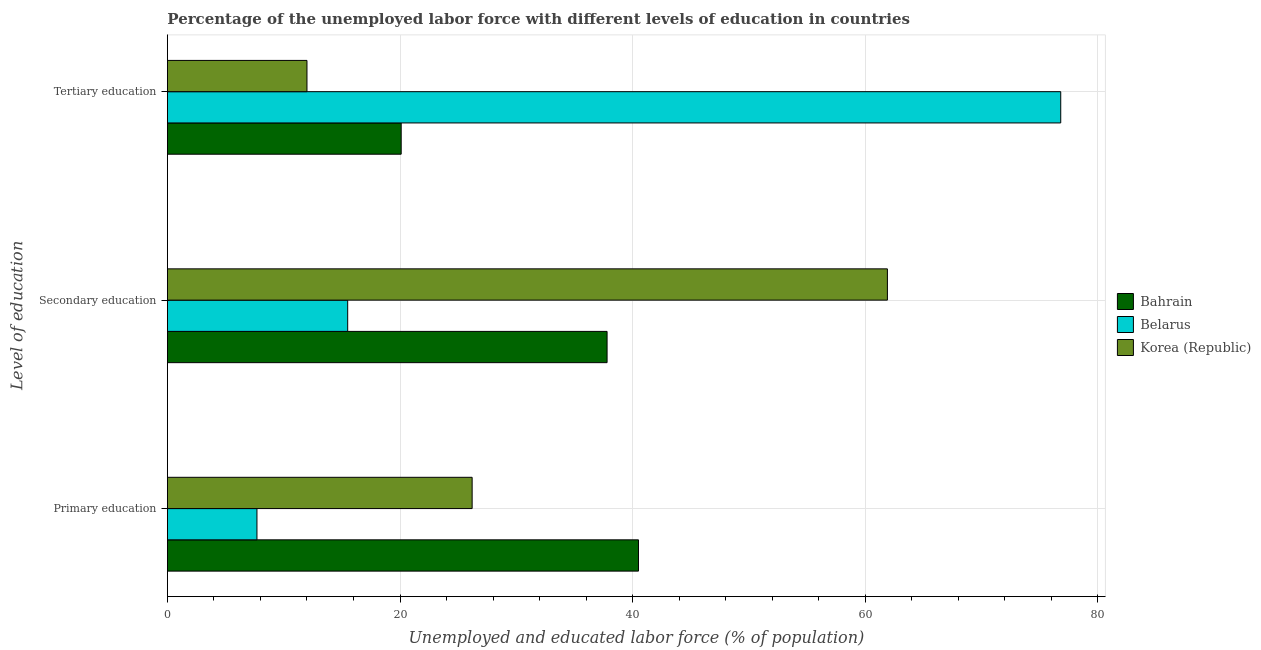Are the number of bars on each tick of the Y-axis equal?
Offer a terse response. Yes. How many bars are there on the 3rd tick from the bottom?
Your response must be concise. 3. What is the label of the 1st group of bars from the top?
Provide a succinct answer. Tertiary education. What is the percentage of labor force who received secondary education in Korea (Republic)?
Offer a terse response. 61.9. Across all countries, what is the maximum percentage of labor force who received primary education?
Offer a very short reply. 40.5. Across all countries, what is the minimum percentage of labor force who received tertiary education?
Provide a succinct answer. 12. In which country was the percentage of labor force who received tertiary education maximum?
Ensure brevity in your answer.  Belarus. In which country was the percentage of labor force who received primary education minimum?
Your answer should be compact. Belarus. What is the total percentage of labor force who received secondary education in the graph?
Give a very brief answer. 115.2. What is the difference between the percentage of labor force who received primary education in Belarus and that in Bahrain?
Ensure brevity in your answer.  -32.8. What is the difference between the percentage of labor force who received primary education in Bahrain and the percentage of labor force who received tertiary education in Korea (Republic)?
Your answer should be compact. 28.5. What is the average percentage of labor force who received primary education per country?
Offer a very short reply. 24.8. What is the difference between the percentage of labor force who received primary education and percentage of labor force who received tertiary education in Bahrain?
Keep it short and to the point. 20.4. What is the ratio of the percentage of labor force who received secondary education in Belarus to that in Korea (Republic)?
Make the answer very short. 0.25. Is the difference between the percentage of labor force who received tertiary education in Korea (Republic) and Bahrain greater than the difference between the percentage of labor force who received secondary education in Korea (Republic) and Bahrain?
Provide a succinct answer. No. What is the difference between the highest and the second highest percentage of labor force who received secondary education?
Offer a terse response. 24.1. What is the difference between the highest and the lowest percentage of labor force who received tertiary education?
Provide a succinct answer. 64.8. What does the 3rd bar from the top in Primary education represents?
Offer a terse response. Bahrain. What does the 3rd bar from the bottom in Tertiary education represents?
Offer a very short reply. Korea (Republic). Is it the case that in every country, the sum of the percentage of labor force who received primary education and percentage of labor force who received secondary education is greater than the percentage of labor force who received tertiary education?
Make the answer very short. No. Are all the bars in the graph horizontal?
Offer a terse response. Yes. Does the graph contain any zero values?
Make the answer very short. No. Where does the legend appear in the graph?
Offer a very short reply. Center right. How many legend labels are there?
Give a very brief answer. 3. What is the title of the graph?
Your answer should be very brief. Percentage of the unemployed labor force with different levels of education in countries. Does "Curacao" appear as one of the legend labels in the graph?
Ensure brevity in your answer.  No. What is the label or title of the X-axis?
Offer a very short reply. Unemployed and educated labor force (% of population). What is the label or title of the Y-axis?
Give a very brief answer. Level of education. What is the Unemployed and educated labor force (% of population) in Bahrain in Primary education?
Provide a succinct answer. 40.5. What is the Unemployed and educated labor force (% of population) in Belarus in Primary education?
Offer a terse response. 7.7. What is the Unemployed and educated labor force (% of population) of Korea (Republic) in Primary education?
Your answer should be compact. 26.2. What is the Unemployed and educated labor force (% of population) of Bahrain in Secondary education?
Offer a very short reply. 37.8. What is the Unemployed and educated labor force (% of population) in Belarus in Secondary education?
Make the answer very short. 15.5. What is the Unemployed and educated labor force (% of population) in Korea (Republic) in Secondary education?
Your response must be concise. 61.9. What is the Unemployed and educated labor force (% of population) in Bahrain in Tertiary education?
Offer a very short reply. 20.1. What is the Unemployed and educated labor force (% of population) in Belarus in Tertiary education?
Offer a terse response. 76.8. What is the Unemployed and educated labor force (% of population) of Korea (Republic) in Tertiary education?
Provide a short and direct response. 12. Across all Level of education, what is the maximum Unemployed and educated labor force (% of population) in Bahrain?
Provide a short and direct response. 40.5. Across all Level of education, what is the maximum Unemployed and educated labor force (% of population) of Belarus?
Offer a very short reply. 76.8. Across all Level of education, what is the maximum Unemployed and educated labor force (% of population) of Korea (Republic)?
Keep it short and to the point. 61.9. Across all Level of education, what is the minimum Unemployed and educated labor force (% of population) in Bahrain?
Provide a succinct answer. 20.1. Across all Level of education, what is the minimum Unemployed and educated labor force (% of population) of Belarus?
Provide a succinct answer. 7.7. What is the total Unemployed and educated labor force (% of population) in Bahrain in the graph?
Your answer should be compact. 98.4. What is the total Unemployed and educated labor force (% of population) of Korea (Republic) in the graph?
Offer a very short reply. 100.1. What is the difference between the Unemployed and educated labor force (% of population) of Bahrain in Primary education and that in Secondary education?
Make the answer very short. 2.7. What is the difference between the Unemployed and educated labor force (% of population) in Korea (Republic) in Primary education and that in Secondary education?
Offer a very short reply. -35.7. What is the difference between the Unemployed and educated labor force (% of population) in Bahrain in Primary education and that in Tertiary education?
Keep it short and to the point. 20.4. What is the difference between the Unemployed and educated labor force (% of population) in Belarus in Primary education and that in Tertiary education?
Provide a succinct answer. -69.1. What is the difference between the Unemployed and educated labor force (% of population) in Belarus in Secondary education and that in Tertiary education?
Ensure brevity in your answer.  -61.3. What is the difference between the Unemployed and educated labor force (% of population) in Korea (Republic) in Secondary education and that in Tertiary education?
Your answer should be compact. 49.9. What is the difference between the Unemployed and educated labor force (% of population) in Bahrain in Primary education and the Unemployed and educated labor force (% of population) in Belarus in Secondary education?
Keep it short and to the point. 25. What is the difference between the Unemployed and educated labor force (% of population) in Bahrain in Primary education and the Unemployed and educated labor force (% of population) in Korea (Republic) in Secondary education?
Your answer should be very brief. -21.4. What is the difference between the Unemployed and educated labor force (% of population) in Belarus in Primary education and the Unemployed and educated labor force (% of population) in Korea (Republic) in Secondary education?
Provide a succinct answer. -54.2. What is the difference between the Unemployed and educated labor force (% of population) in Bahrain in Primary education and the Unemployed and educated labor force (% of population) in Belarus in Tertiary education?
Offer a very short reply. -36.3. What is the difference between the Unemployed and educated labor force (% of population) of Bahrain in Primary education and the Unemployed and educated labor force (% of population) of Korea (Republic) in Tertiary education?
Your response must be concise. 28.5. What is the difference between the Unemployed and educated labor force (% of population) of Bahrain in Secondary education and the Unemployed and educated labor force (% of population) of Belarus in Tertiary education?
Provide a succinct answer. -39. What is the difference between the Unemployed and educated labor force (% of population) in Bahrain in Secondary education and the Unemployed and educated labor force (% of population) in Korea (Republic) in Tertiary education?
Offer a very short reply. 25.8. What is the average Unemployed and educated labor force (% of population) in Bahrain per Level of education?
Your answer should be compact. 32.8. What is the average Unemployed and educated labor force (% of population) of Belarus per Level of education?
Keep it short and to the point. 33.33. What is the average Unemployed and educated labor force (% of population) of Korea (Republic) per Level of education?
Offer a terse response. 33.37. What is the difference between the Unemployed and educated labor force (% of population) of Bahrain and Unemployed and educated labor force (% of population) of Belarus in Primary education?
Make the answer very short. 32.8. What is the difference between the Unemployed and educated labor force (% of population) of Belarus and Unemployed and educated labor force (% of population) of Korea (Republic) in Primary education?
Your response must be concise. -18.5. What is the difference between the Unemployed and educated labor force (% of population) in Bahrain and Unemployed and educated labor force (% of population) in Belarus in Secondary education?
Your answer should be very brief. 22.3. What is the difference between the Unemployed and educated labor force (% of population) in Bahrain and Unemployed and educated labor force (% of population) in Korea (Republic) in Secondary education?
Provide a short and direct response. -24.1. What is the difference between the Unemployed and educated labor force (% of population) in Belarus and Unemployed and educated labor force (% of population) in Korea (Republic) in Secondary education?
Provide a short and direct response. -46.4. What is the difference between the Unemployed and educated labor force (% of population) in Bahrain and Unemployed and educated labor force (% of population) in Belarus in Tertiary education?
Give a very brief answer. -56.7. What is the difference between the Unemployed and educated labor force (% of population) in Belarus and Unemployed and educated labor force (% of population) in Korea (Republic) in Tertiary education?
Your response must be concise. 64.8. What is the ratio of the Unemployed and educated labor force (% of population) of Bahrain in Primary education to that in Secondary education?
Your answer should be compact. 1.07. What is the ratio of the Unemployed and educated labor force (% of population) of Belarus in Primary education to that in Secondary education?
Offer a terse response. 0.5. What is the ratio of the Unemployed and educated labor force (% of population) in Korea (Republic) in Primary education to that in Secondary education?
Keep it short and to the point. 0.42. What is the ratio of the Unemployed and educated labor force (% of population) of Bahrain in Primary education to that in Tertiary education?
Give a very brief answer. 2.01. What is the ratio of the Unemployed and educated labor force (% of population) in Belarus in Primary education to that in Tertiary education?
Make the answer very short. 0.1. What is the ratio of the Unemployed and educated labor force (% of population) of Korea (Republic) in Primary education to that in Tertiary education?
Your response must be concise. 2.18. What is the ratio of the Unemployed and educated labor force (% of population) in Bahrain in Secondary education to that in Tertiary education?
Make the answer very short. 1.88. What is the ratio of the Unemployed and educated labor force (% of population) in Belarus in Secondary education to that in Tertiary education?
Offer a very short reply. 0.2. What is the ratio of the Unemployed and educated labor force (% of population) of Korea (Republic) in Secondary education to that in Tertiary education?
Your answer should be very brief. 5.16. What is the difference between the highest and the second highest Unemployed and educated labor force (% of population) in Belarus?
Your answer should be compact. 61.3. What is the difference between the highest and the second highest Unemployed and educated labor force (% of population) of Korea (Republic)?
Give a very brief answer. 35.7. What is the difference between the highest and the lowest Unemployed and educated labor force (% of population) of Bahrain?
Ensure brevity in your answer.  20.4. What is the difference between the highest and the lowest Unemployed and educated labor force (% of population) of Belarus?
Provide a short and direct response. 69.1. What is the difference between the highest and the lowest Unemployed and educated labor force (% of population) in Korea (Republic)?
Give a very brief answer. 49.9. 